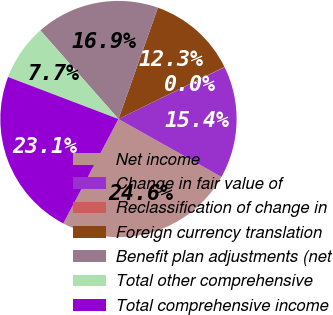Convert chart to OTSL. <chart><loc_0><loc_0><loc_500><loc_500><pie_chart><fcel>Net income<fcel>Change in fair value of<fcel>Reclassification of change in<fcel>Foreign currency translation<fcel>Benefit plan adjustments (net<fcel>Total other comprehensive<fcel>Total comprehensive income<nl><fcel>24.58%<fcel>15.38%<fcel>0.04%<fcel>12.31%<fcel>16.91%<fcel>7.71%<fcel>23.05%<nl></chart> 